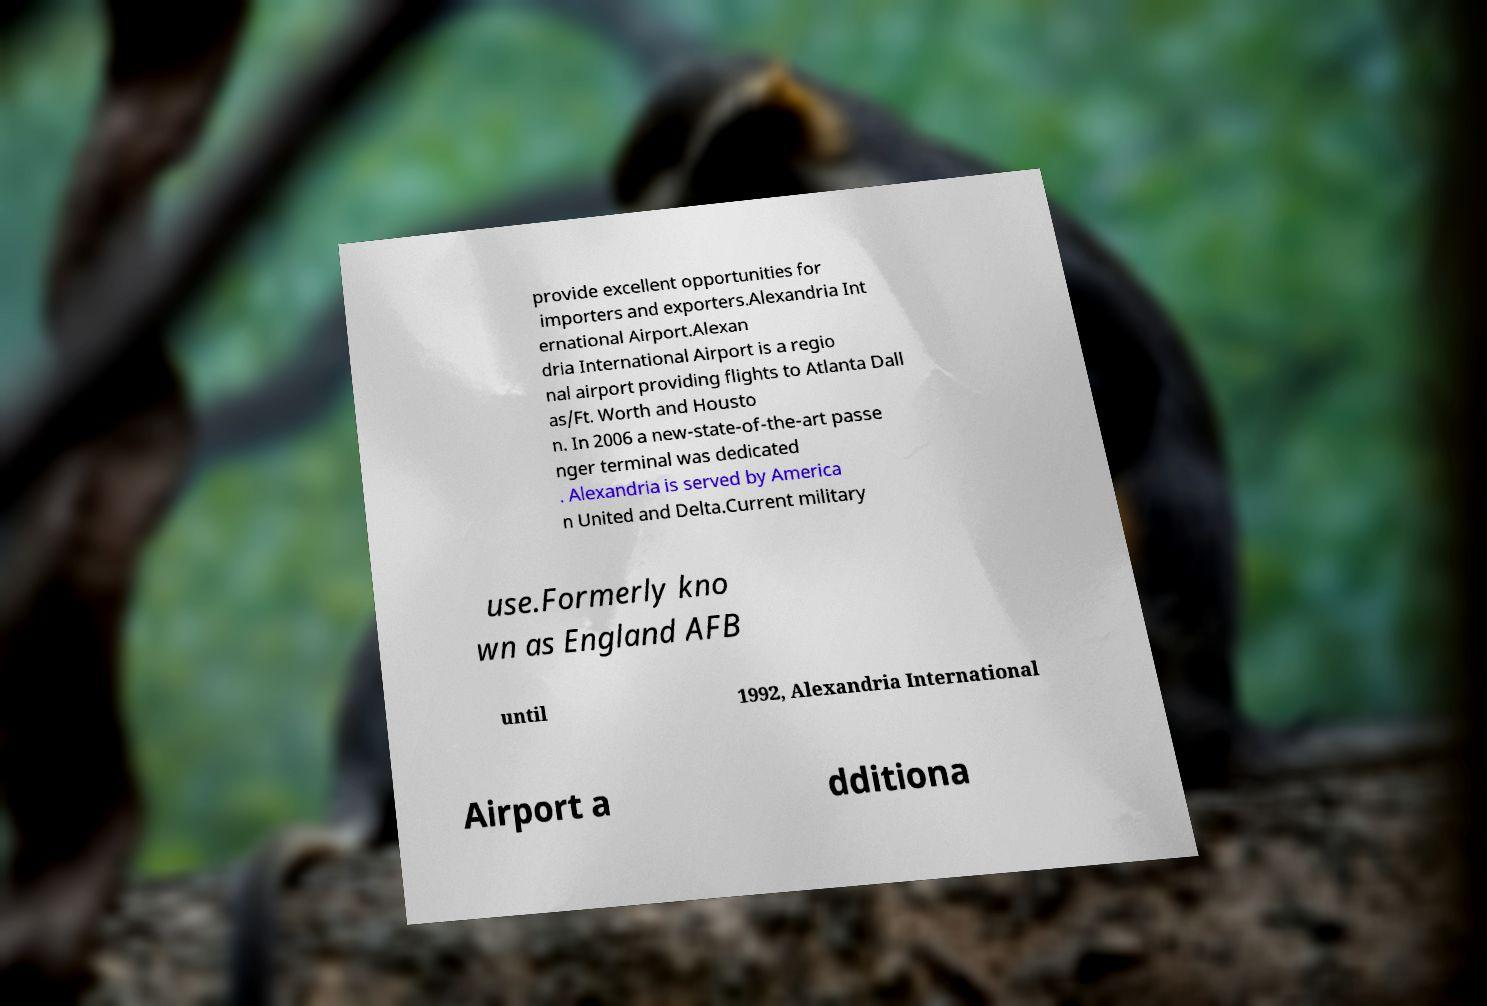Can you accurately transcribe the text from the provided image for me? provide excellent opportunities for importers and exporters.Alexandria Int ernational Airport.Alexan dria International Airport is a regio nal airport providing flights to Atlanta Dall as/Ft. Worth and Housto n. In 2006 a new-state-of-the-art passe nger terminal was dedicated . Alexandria is served by America n United and Delta.Current military use.Formerly kno wn as England AFB until 1992, Alexandria International Airport a dditiona 